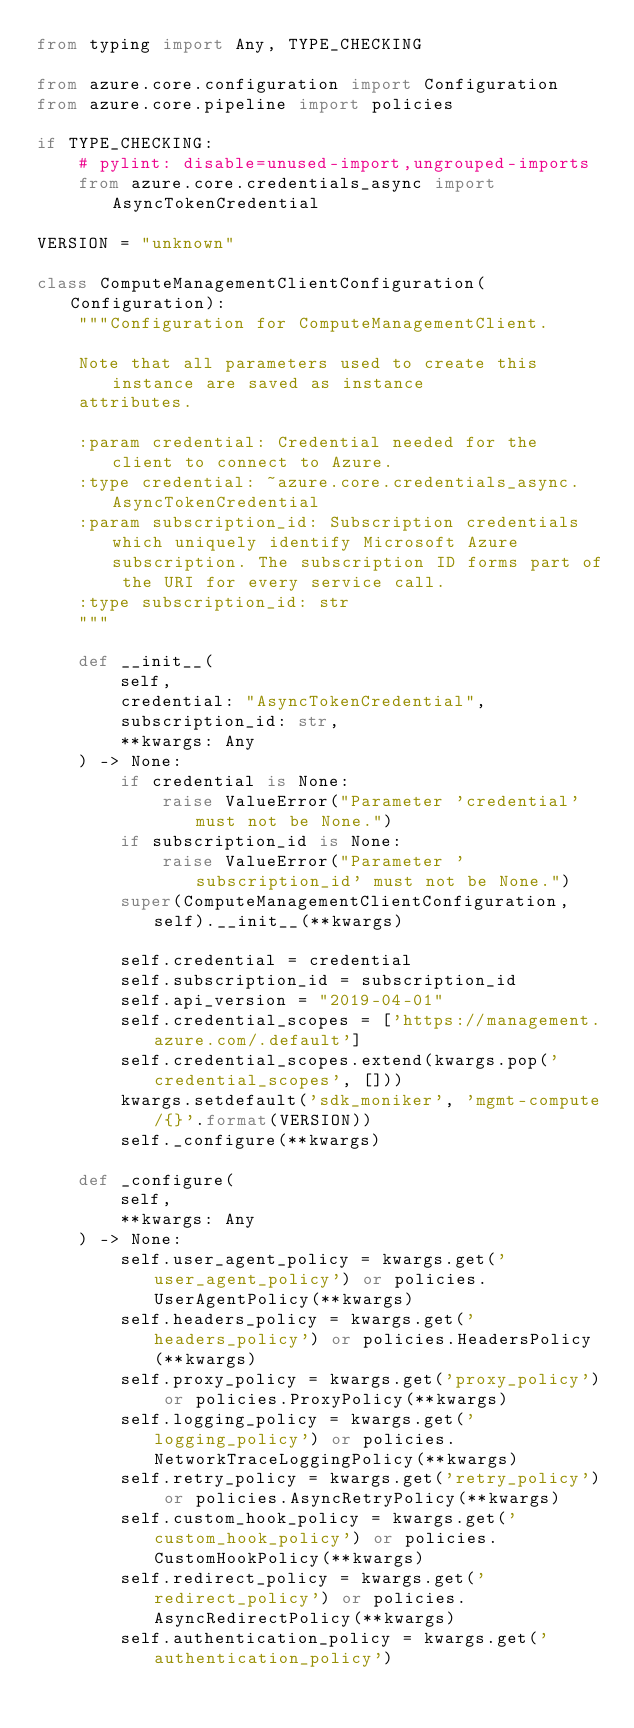<code> <loc_0><loc_0><loc_500><loc_500><_Python_>from typing import Any, TYPE_CHECKING

from azure.core.configuration import Configuration
from azure.core.pipeline import policies

if TYPE_CHECKING:
    # pylint: disable=unused-import,ungrouped-imports
    from azure.core.credentials_async import AsyncTokenCredential

VERSION = "unknown"

class ComputeManagementClientConfiguration(Configuration):
    """Configuration for ComputeManagementClient.

    Note that all parameters used to create this instance are saved as instance
    attributes.

    :param credential: Credential needed for the client to connect to Azure.
    :type credential: ~azure.core.credentials_async.AsyncTokenCredential
    :param subscription_id: Subscription credentials which uniquely identify Microsoft Azure subscription. The subscription ID forms part of the URI for every service call.
    :type subscription_id: str
    """

    def __init__(
        self,
        credential: "AsyncTokenCredential",
        subscription_id: str,
        **kwargs: Any
    ) -> None:
        if credential is None:
            raise ValueError("Parameter 'credential' must not be None.")
        if subscription_id is None:
            raise ValueError("Parameter 'subscription_id' must not be None.")
        super(ComputeManagementClientConfiguration, self).__init__(**kwargs)

        self.credential = credential
        self.subscription_id = subscription_id
        self.api_version = "2019-04-01"
        self.credential_scopes = ['https://management.azure.com/.default']
        self.credential_scopes.extend(kwargs.pop('credential_scopes', []))
        kwargs.setdefault('sdk_moniker', 'mgmt-compute/{}'.format(VERSION))
        self._configure(**kwargs)

    def _configure(
        self,
        **kwargs: Any
    ) -> None:
        self.user_agent_policy = kwargs.get('user_agent_policy') or policies.UserAgentPolicy(**kwargs)
        self.headers_policy = kwargs.get('headers_policy') or policies.HeadersPolicy(**kwargs)
        self.proxy_policy = kwargs.get('proxy_policy') or policies.ProxyPolicy(**kwargs)
        self.logging_policy = kwargs.get('logging_policy') or policies.NetworkTraceLoggingPolicy(**kwargs)
        self.retry_policy = kwargs.get('retry_policy') or policies.AsyncRetryPolicy(**kwargs)
        self.custom_hook_policy = kwargs.get('custom_hook_policy') or policies.CustomHookPolicy(**kwargs)
        self.redirect_policy = kwargs.get('redirect_policy') or policies.AsyncRedirectPolicy(**kwargs)
        self.authentication_policy = kwargs.get('authentication_policy')</code> 